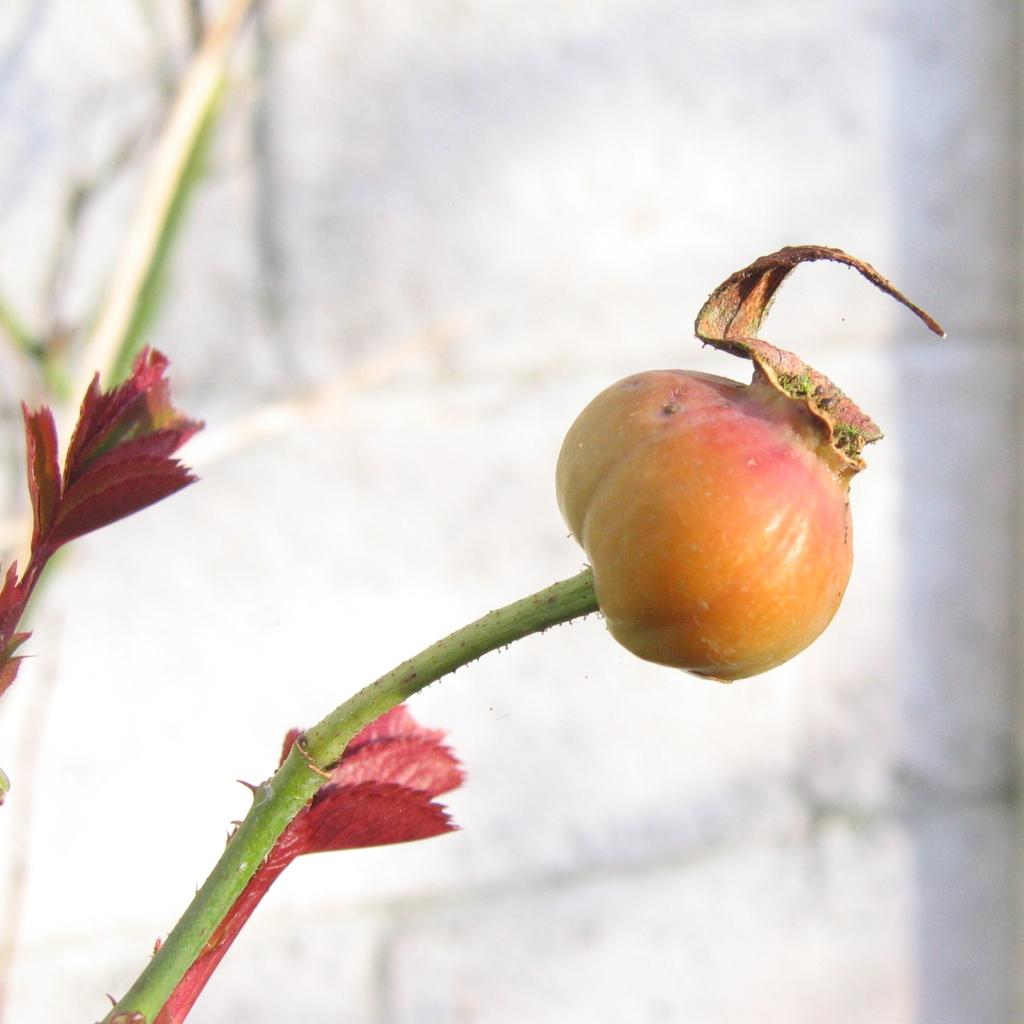What is the main subject in the foreground of the image? There is a rose hip in the foreground of the image. How is the rose hip connected to the rest of the plant? The rose hip is attached to a stem. What can be seen in the background of the image? There are red-colored leafs and a wall visible in the background of the image. What type of glass can be seen in the image? There is no glass present in the image; it features a rose hip, stem, red-colored leafs, and a wall in the background. 